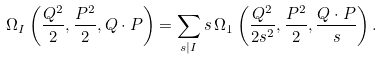<formula> <loc_0><loc_0><loc_500><loc_500>\Omega _ { I } \left ( \frac { Q ^ { 2 } } { 2 } , \frac { P ^ { 2 } } { 2 } , Q \cdot P \right ) = \sum _ { s | I } s \, \Omega _ { 1 } \left ( \frac { Q ^ { 2 } } { 2 s ^ { 2 } } , \frac { P ^ { 2 } } { 2 } , \frac { Q \cdot P } { s } \right ) .</formula> 